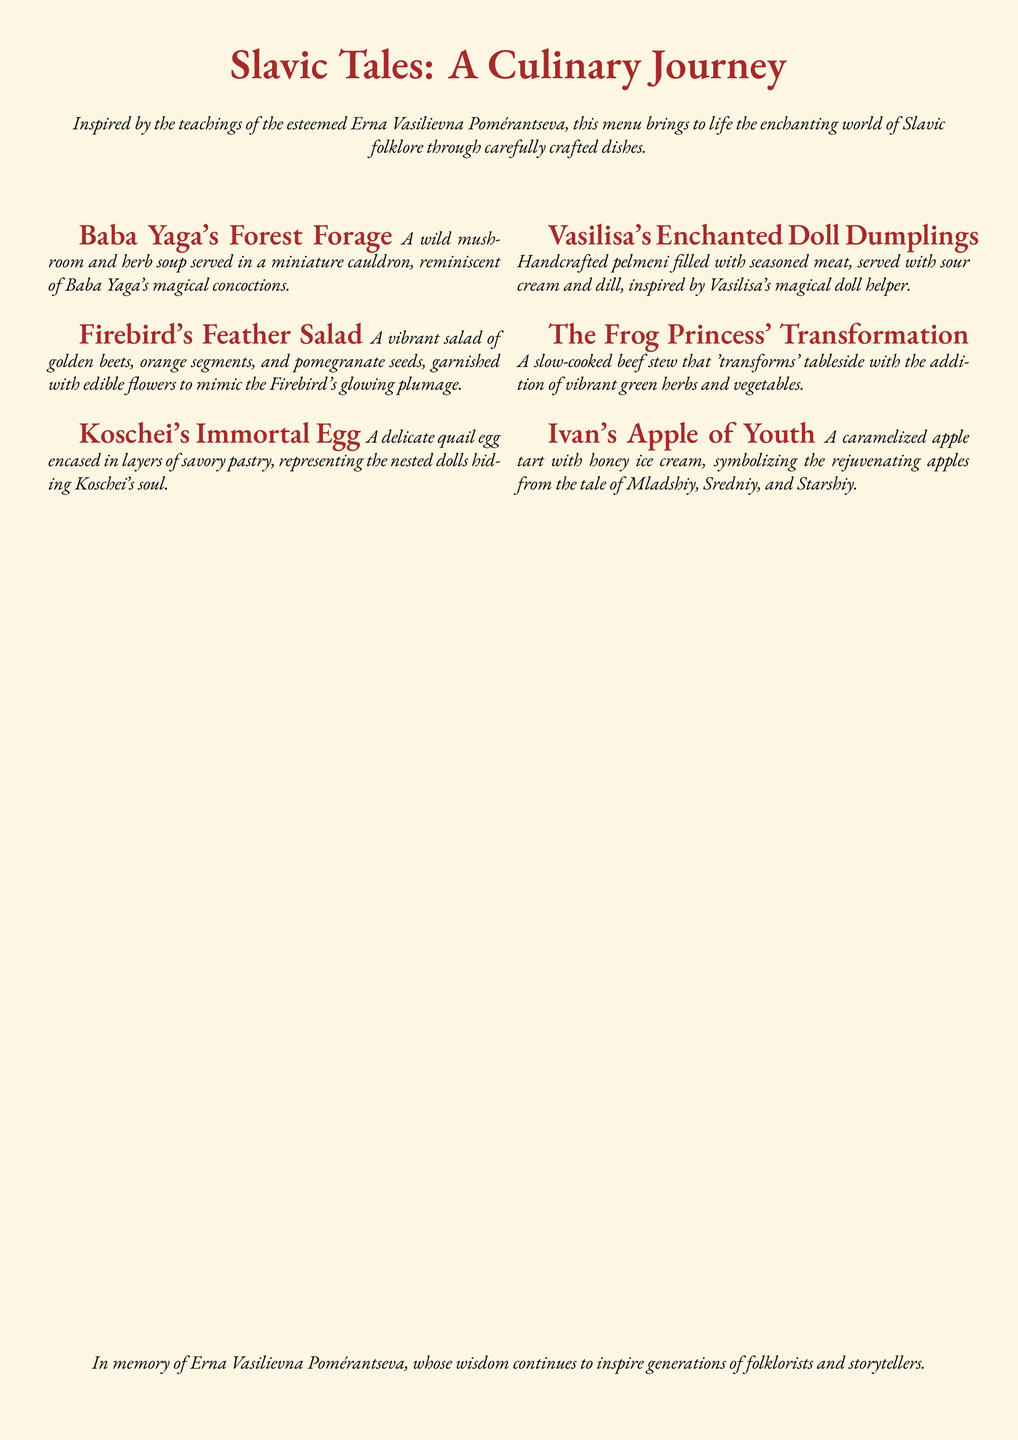What is the title of the menu? The title of the menu appears prominently at the top of the document and is "Slavic Tales: A Culinary Journey."
Answer: Slavic Tales: A Culinary Journey Who is the inspiration behind the menu? The menu credits the esteemed Erna Vasilievna Pomérantseva as the source of inspiration, as mentioned in the introduction.
Answer: Erna Vasilievna Pomérantseva What course is inspired by Baba Yaga? The course inspired by Baba Yaga is described in the first item of the menu.
Answer: Baba Yaga's Forest Forage What dish represents the Firebird? The dish that represents the Firebird is detailed in the second course description.
Answer: Firebird's Feather Salad How is Koschei's soul represented in the menu? The representation of Koschei's soul is found in the description of one particular dish detailing its preparation.
Answer: Immortal Egg What is included in Vasilisa's dish? The description of Vasilisa's dish mentions its components, one of which is included in the description of the dish.
Answer: dumplings What transformation occurs in the Frog Princess dish? The transformation mentioned in the menu is related to a cooking process described in the dish's name.
Answer: tableside How many main courses are listed in the menu? The menu includes a total of six distinct courses based on Slavic fairy tales, as can be counted within the listed sections.
Answer: six What does Ivan's dish symbolize? The symbolism attributed to Ivan's dish is clearly stated in the description of its contents.
Answer: rejuvenating apples 